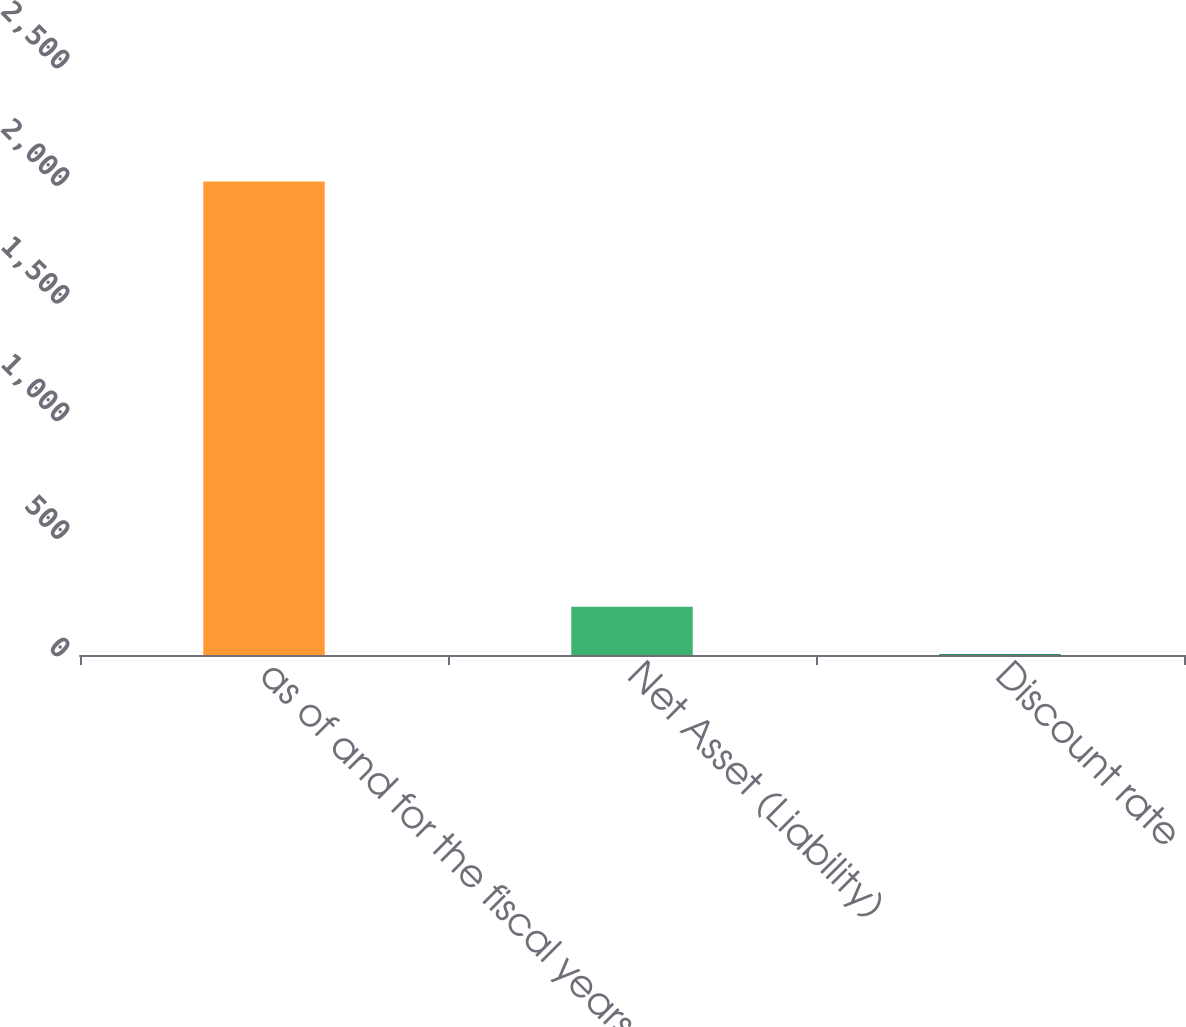Convert chart to OTSL. <chart><loc_0><loc_0><loc_500><loc_500><bar_chart><fcel>as of and for the fiscal years<fcel>Net Asset (Liability)<fcel>Discount rate<nl><fcel>2013<fcel>205.4<fcel>4.55<nl></chart> 